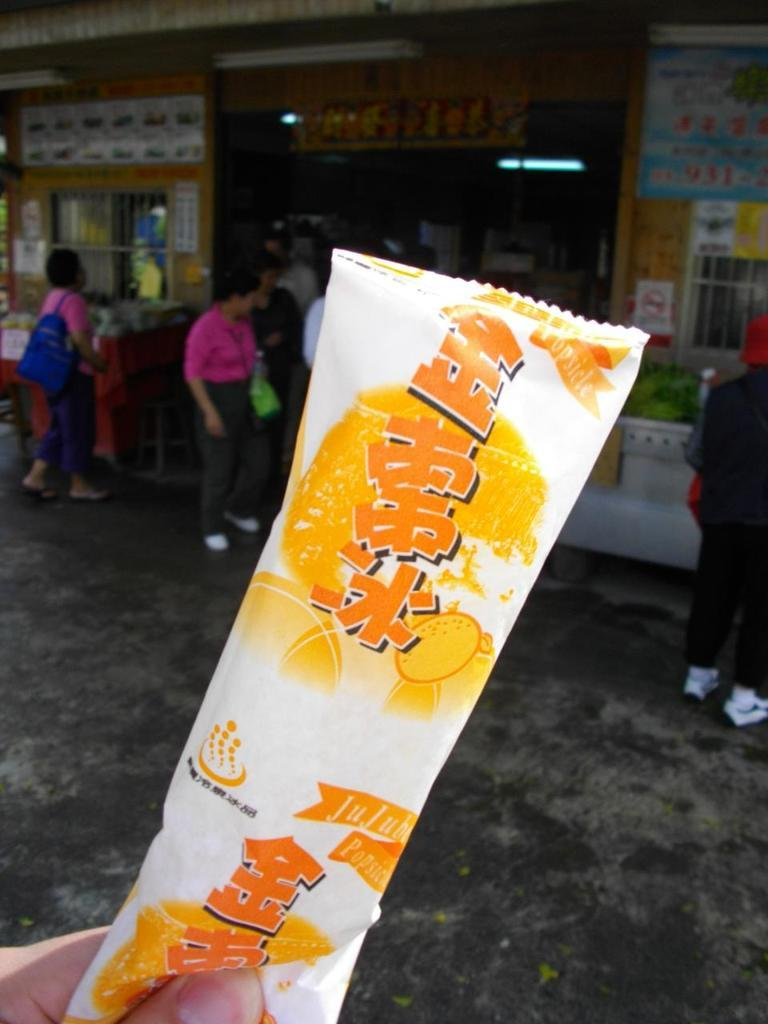What is happening in the image involving the persons near the building? There are many persons standing near a building in the image. Can you describe the action of the person with the cover in the image? There is a person standing and catching a cover with text in the image. What type of water is being used to paint on the canvas in the image? There is no canvas or water present in the image; it features persons standing near a building and a person catching a cover with text. 